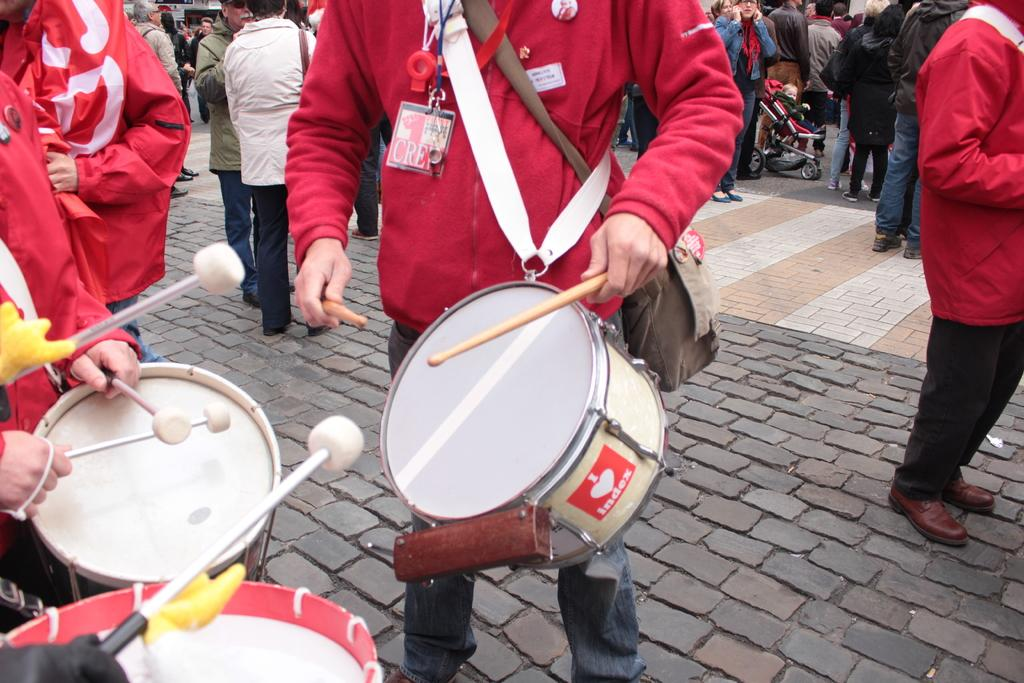What is happening on the left side of the image? There is a group of persons standing on the left side of the image. What are the persons on the left side of the image doing? The group of persons is playing drums. Are there any other people visible in the image? Yes, there are some persons standing in the background of the image. What type of roof can be seen in the image? There is no roof visible in the image; it is focused on the group of persons playing drums. 